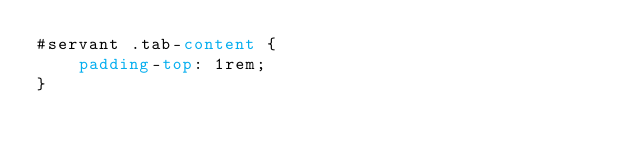<code> <loc_0><loc_0><loc_500><loc_500><_CSS_>#servant .tab-content {
    padding-top: 1rem;
}
</code> 